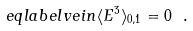<formula> <loc_0><loc_0><loc_500><loc_500>\ e q l a b e l { v e i n } \langle E ^ { 3 } \rangle _ { 0 , 1 } = 0 \ .</formula> 